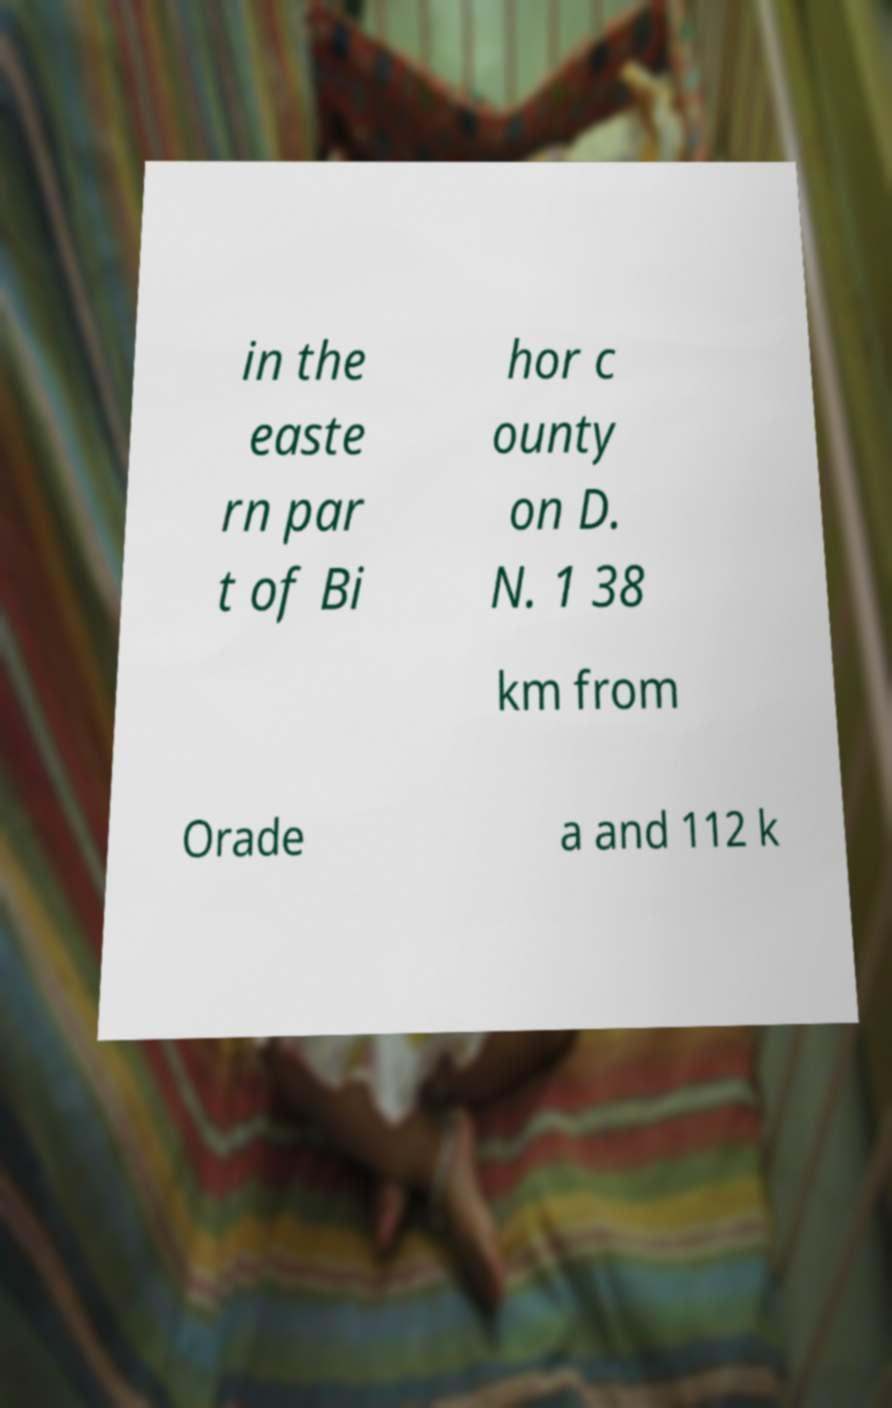Could you assist in decoding the text presented in this image and type it out clearly? in the easte rn par t of Bi hor c ounty on D. N. 1 38 km from Orade a and 112 k 